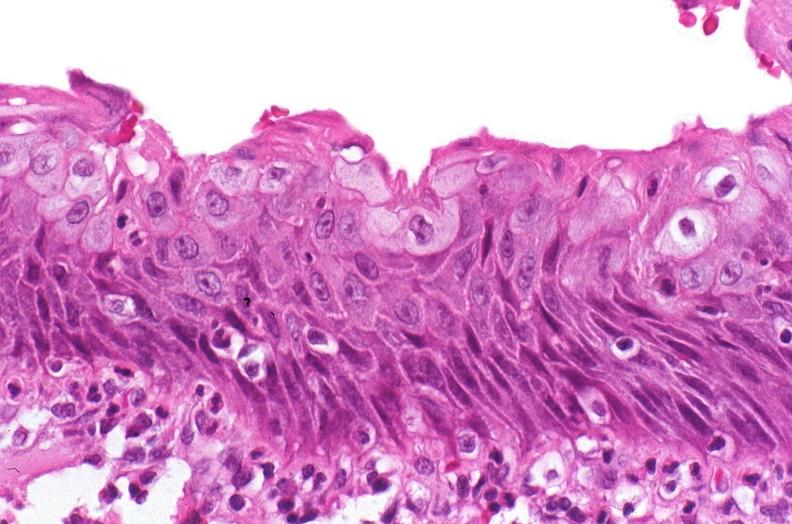does decubitus ulcer show renal pelvis, squamous metaplasia due to chronic urolithiasis?
Answer the question using a single word or phrase. No 